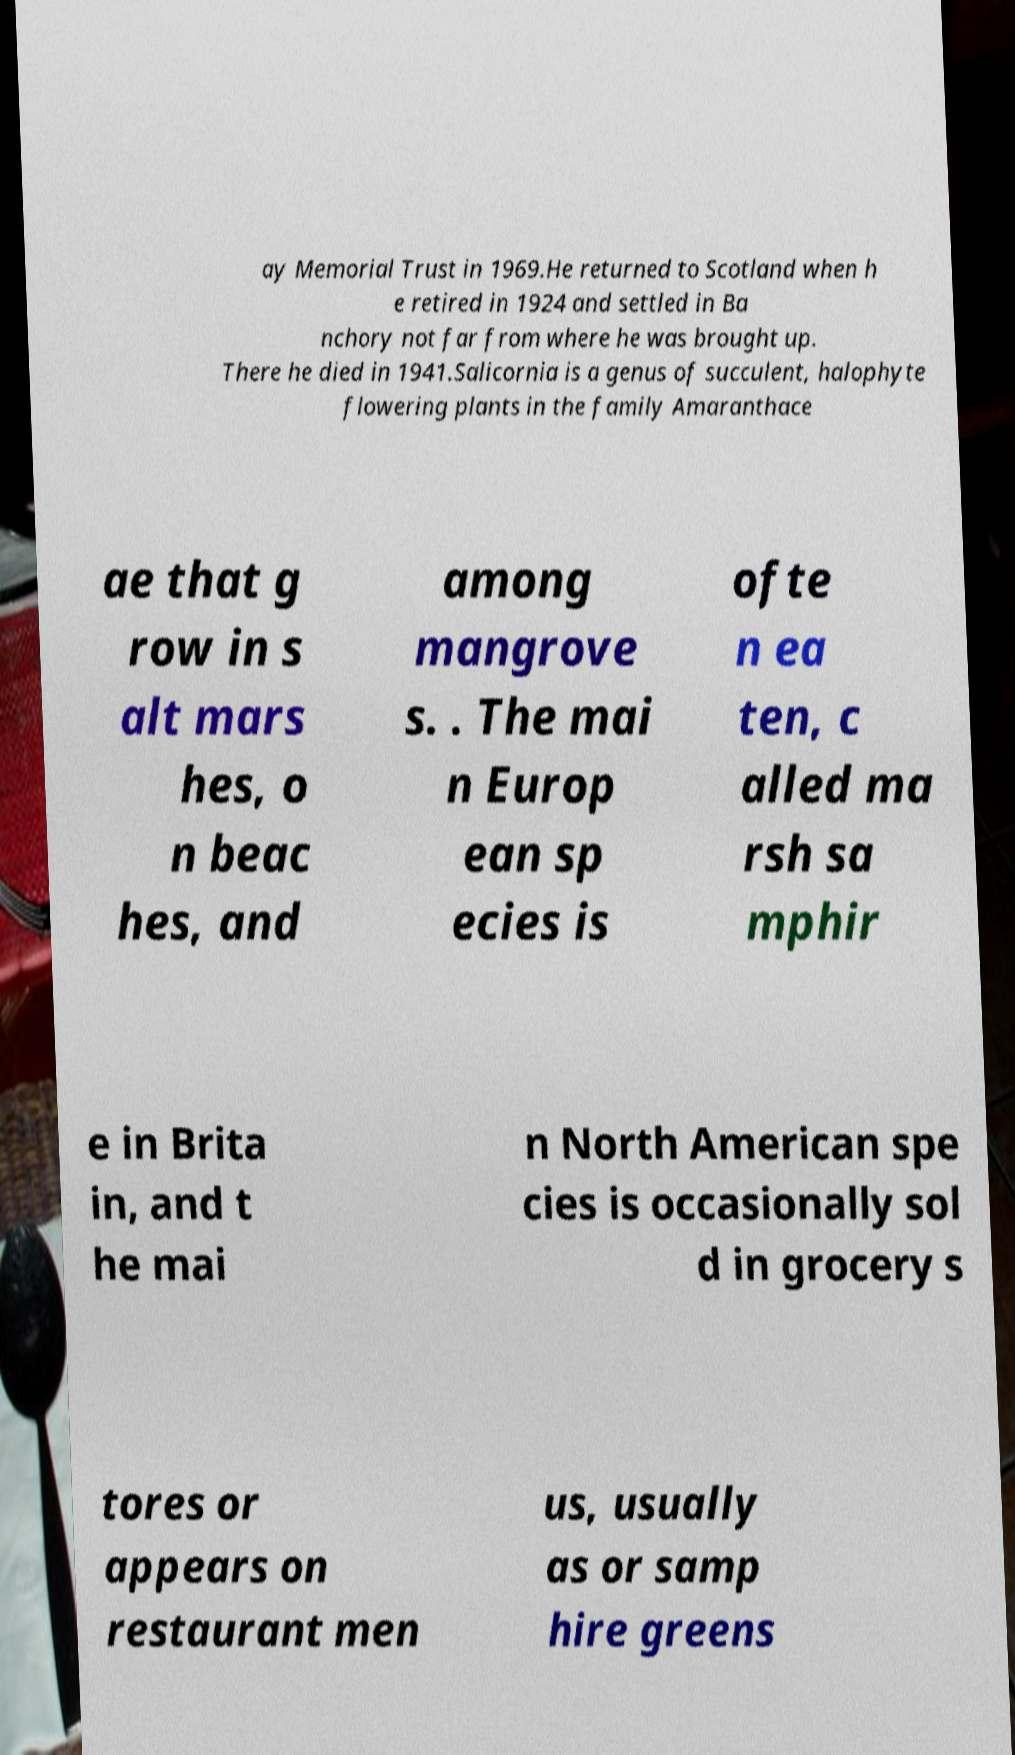Could you assist in decoding the text presented in this image and type it out clearly? ay Memorial Trust in 1969.He returned to Scotland when h e retired in 1924 and settled in Ba nchory not far from where he was brought up. There he died in 1941.Salicornia is a genus of succulent, halophyte flowering plants in the family Amaranthace ae that g row in s alt mars hes, o n beac hes, and among mangrove s. . The mai n Europ ean sp ecies is ofte n ea ten, c alled ma rsh sa mphir e in Brita in, and t he mai n North American spe cies is occasionally sol d in grocery s tores or appears on restaurant men us, usually as or samp hire greens 